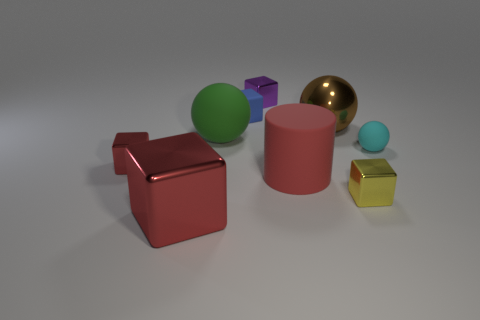The metal thing that is the same color as the big shiny cube is what size?
Keep it short and to the point. Small. There is a big rubber object that is the same shape as the brown metal thing; what color is it?
Offer a terse response. Green. Do the large metal object that is in front of the big red cylinder and the large cylinder have the same color?
Offer a terse response. Yes. Is there any other thing of the same color as the small matte ball?
Your answer should be very brief. No. Do the cyan matte object and the yellow shiny object have the same size?
Make the answer very short. Yes. What is the size of the metal object that is both to the right of the large red cylinder and behind the yellow metallic cube?
Your answer should be very brief. Large. What number of tiny red blocks are the same material as the brown ball?
Offer a very short reply. 1. The large thing that is the same color as the big cylinder is what shape?
Provide a short and direct response. Cube. The big metallic sphere has what color?
Keep it short and to the point. Brown. There is a big thing in front of the red cylinder; is it the same shape as the yellow metal thing?
Offer a terse response. Yes. 